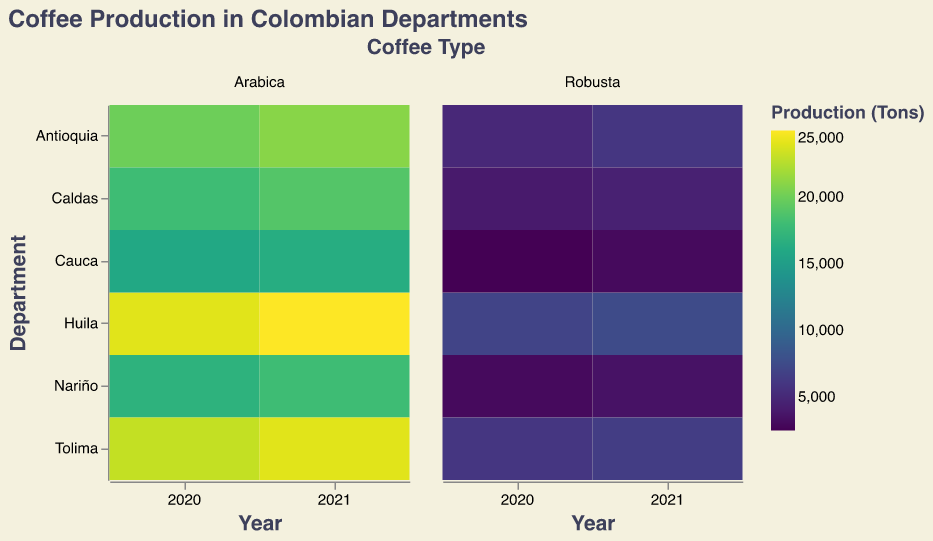Which department had the highest total coffee production in 2020? By looking at the darker shades in 2020, we can see that Huila had a significant production, but adding up the values for each department we find, Huila: 31000 tons (24000 Arabica + 7000 Robusta), while Tolima had 29000 tons (23000 Arabica + 6000 Robusta), hence confirming Huila's production.
Answer: Huila Which coffee type saw the largest increase in production from 2020 to 2021 in the department of Antioquia? For Antioquia, compare the production of each coffee type for 2020 and 2021. Arabica increased from 20000 to 21000 tons (1000 tons increase), and Robusta increased from 5000 to 6000 tons (1000 tons increase). Both increases are equal.
Answer: Both Arabica and Robusta In which year did Cauca produce more Robusta coffee? Comparing the data for Cauca's Robusta production in 2020 and 2021, we find 2500 tons in 2020 and 3000 tons in 2021.
Answer: 2021 How does the Arabica coffee production of Caldas in 2020 compare to that in 2021? Look at the production values for Arabica coffee in Caldas for both years. In 2020, it was 18000 tons, and in 2021 it was 19000 tons.
Answer: 2021 is higher Which department had the smallest production of Robusta coffee in 2020? Reviewing the figures for all departments in 2020, it is shown that Cauca had the smallest production, with 2500 tons.
Answer: Cauca What is the difference in Arabica coffee production between Huila and Tolima in 2021? Calculate the difference by subtracting the Arabica production of Huila from that of Tolima in 2021. Tolima produced 24000 tons, while Huila produced 25000 tons. The difference is 25000 - 24000 = 1000 tons.
Answer: 1000 tons Compare the total coffee production of Nariño across both years. Was there an increase or decrease? For Nariño, sum the Arabica and Robusta production for each year. In 2020, it amounts to 20000 tons (17000 + 3000), and in 2021, it sums to 21500 tons (18000 + 3500). There was an increase.
Answer: Increase 